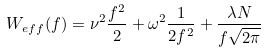<formula> <loc_0><loc_0><loc_500><loc_500>W _ { e f f } ( f ) = \nu ^ { 2 } \frac { f ^ { 2 } } { 2 } + \omega ^ { 2 } \frac { 1 } { 2 f ^ { 2 } } + \frac { \lambda N } { f \sqrt { 2 \pi } }</formula> 